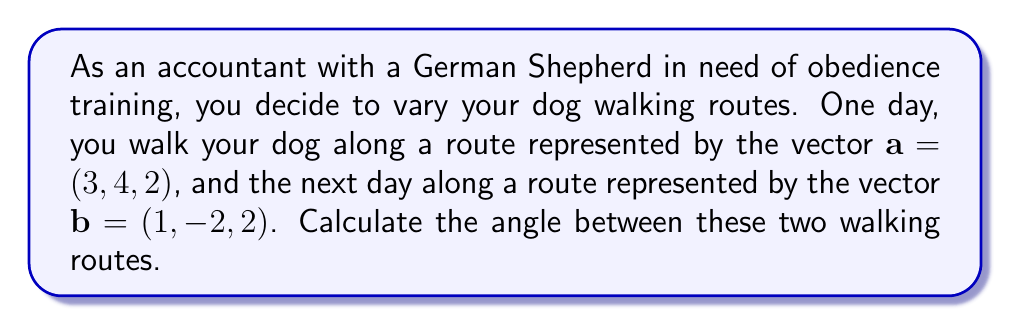Show me your answer to this math problem. To find the angle between two vectors, we can use the dot product formula:

$$\cos \theta = \frac{\mathbf{a} \cdot \mathbf{b}}{|\mathbf{a}||\mathbf{b}|}$$

Where $\mathbf{a} \cdot \mathbf{b}$ is the dot product of the vectors, and $|\mathbf{a}|$ and $|\mathbf{b}|$ are the magnitudes of the vectors.

Step 1: Calculate the dot product $\mathbf{a} \cdot \mathbf{b}$
$$\mathbf{a} \cdot \mathbf{b} = (3)(1) + (4)(-2) + (2)(2) = 3 - 8 + 4 = -1$$

Step 2: Calculate the magnitudes of $\mathbf{a}$ and $\mathbf{b}$
$$|\mathbf{a}| = \sqrt{3^2 + 4^2 + 2^2} = \sqrt{9 + 16 + 4} = \sqrt{29}$$
$$|\mathbf{b}| = \sqrt{1^2 + (-2)^2 + 2^2} = \sqrt{1 + 4 + 4} = 3$$

Step 3: Substitute into the formula
$$\cos \theta = \frac{-1}{\sqrt{29} \cdot 3}$$

Step 4: Solve for $\theta$
$$\theta = \arccos\left(\frac{-1}{\sqrt{29} \cdot 3}\right)$$

Step 5: Calculate the result (rounded to two decimal places)
$$\theta \approx 1.76 \text{ radians} \approx 100.89\text{°}$$
Answer: The angle between the two dog walking routes is approximately 1.76 radians or 100.89°. 